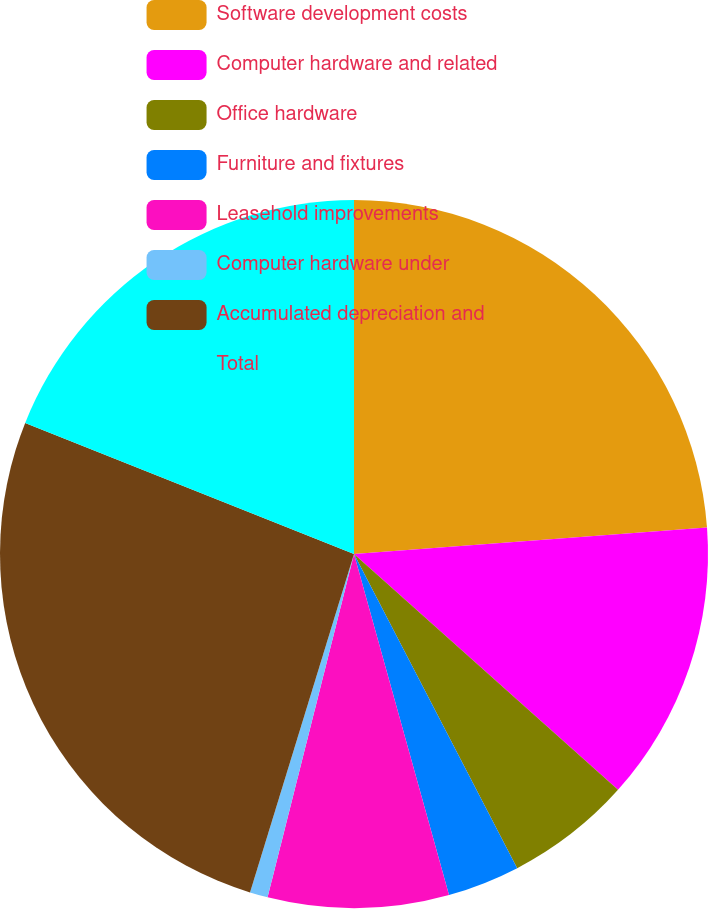Convert chart to OTSL. <chart><loc_0><loc_0><loc_500><loc_500><pie_chart><fcel>Software development costs<fcel>Computer hardware and related<fcel>Office hardware<fcel>Furniture and fixtures<fcel>Leasehold improvements<fcel>Computer hardware under<fcel>Accumulated depreciation and<fcel>Total<nl><fcel>23.81%<fcel>12.79%<fcel>5.77%<fcel>3.3%<fcel>8.25%<fcel>0.82%<fcel>26.29%<fcel>18.96%<nl></chart> 